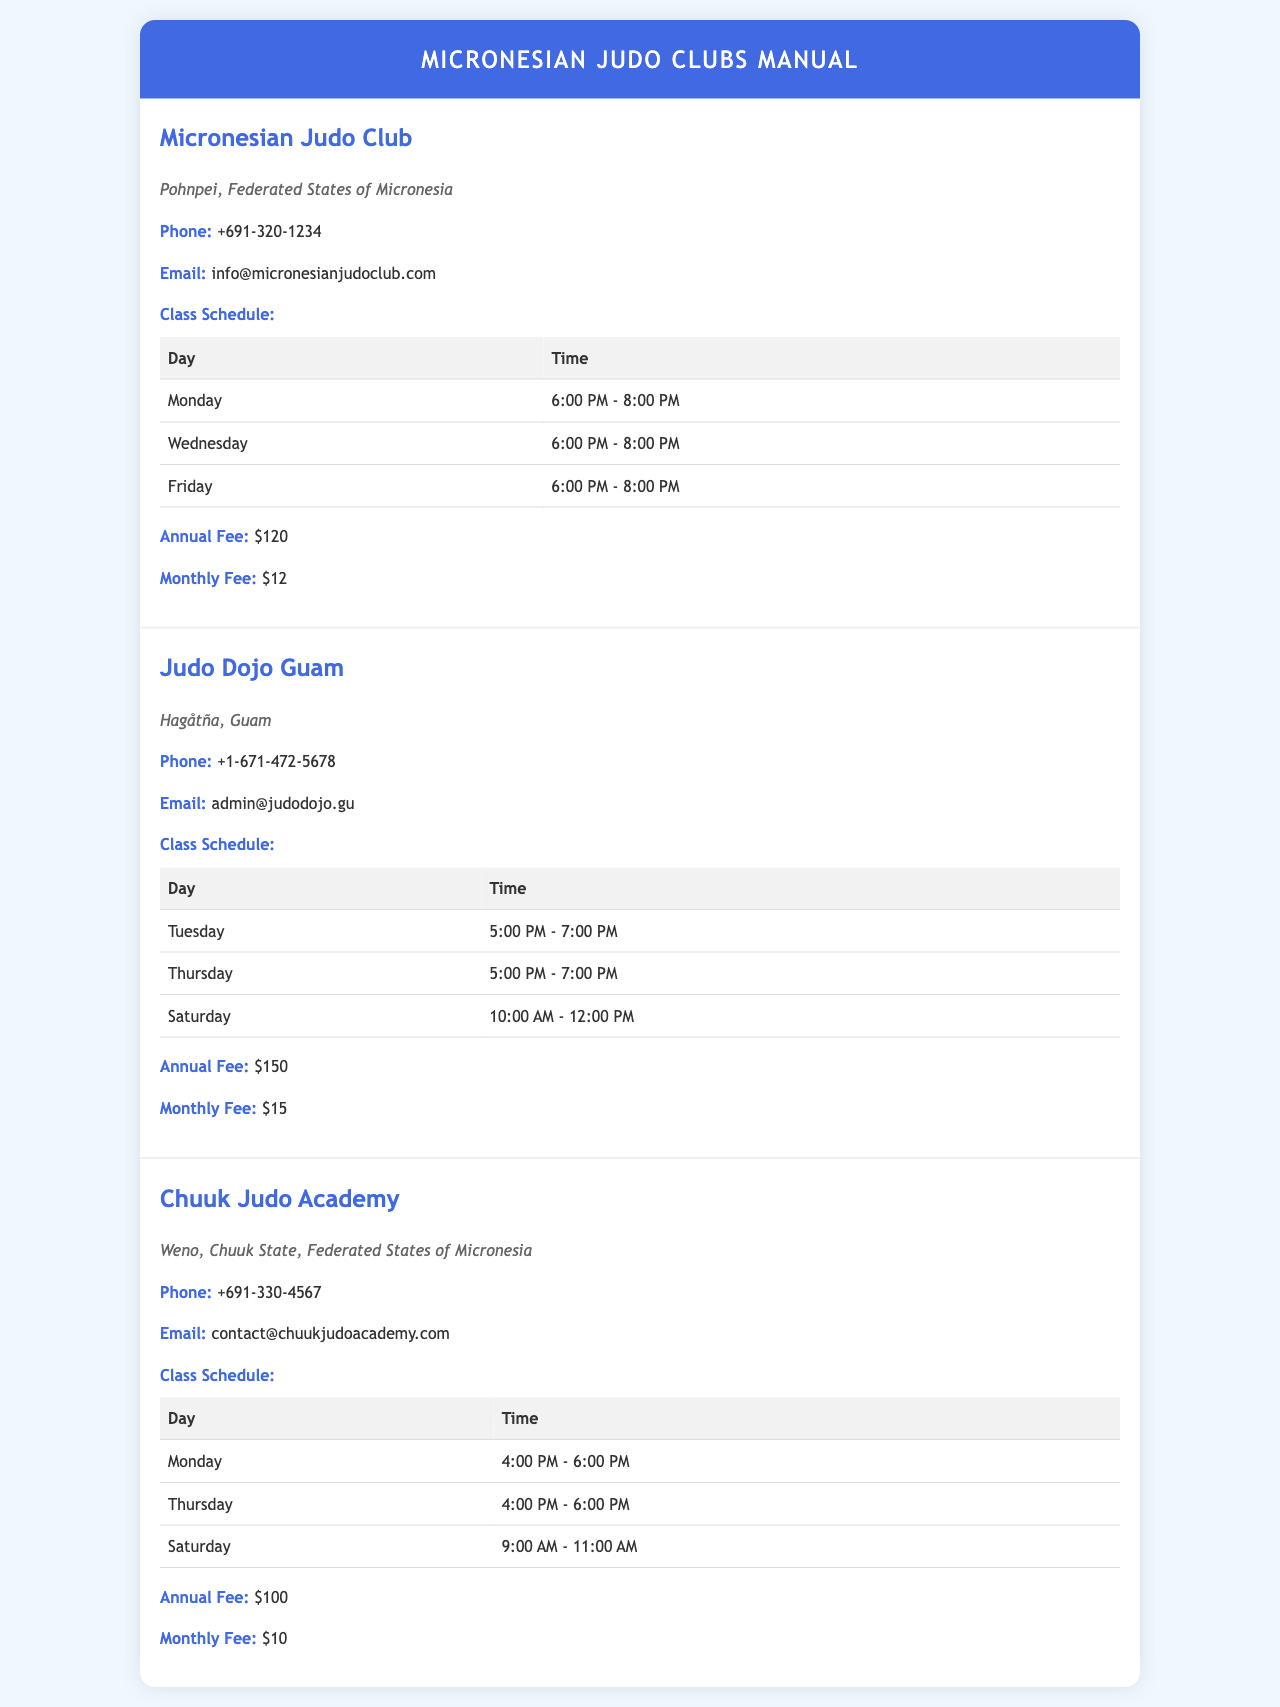What is the phone number for Micronesian Judo Club? The phone number for Micronesian Judo Club is listed in their contact section.
Answer: +691-320-1234 What are the class days for Judo Dojo Guam? Judo Dojo Guam's class schedule includes specific days listed in a table.
Answer: Tuesday, Thursday, Saturday What is the annual fee for Chuuk Judo Academy? The annual fee for Chuuk Judo Academy is provided in the fees section.
Answer: $100 What time do classes start on Mondays at Micronesian Judo Club? The class schedule specifies the start time for Monday classes at Micronesian Judo Club.
Answer: 6:00 PM How many classes does Judo Dojo Guam offer each week? The class schedule lists multiple days for classes, providing the total count.
Answer: Three classes What is the email address for Judo Dojo Guam? The email address is mentioned in the contact section of the document.
Answer: admin@judodojo.gu Which dojo has the lowest monthly fee? By comparing the monthly fees listed for each club, the answer can be determined.
Answer: Chuuk Judo Academy Where is Micronesian Judo Club located? The location is specified in the description of the club.
Answer: Pohnpei, Federated States of Micronesia 